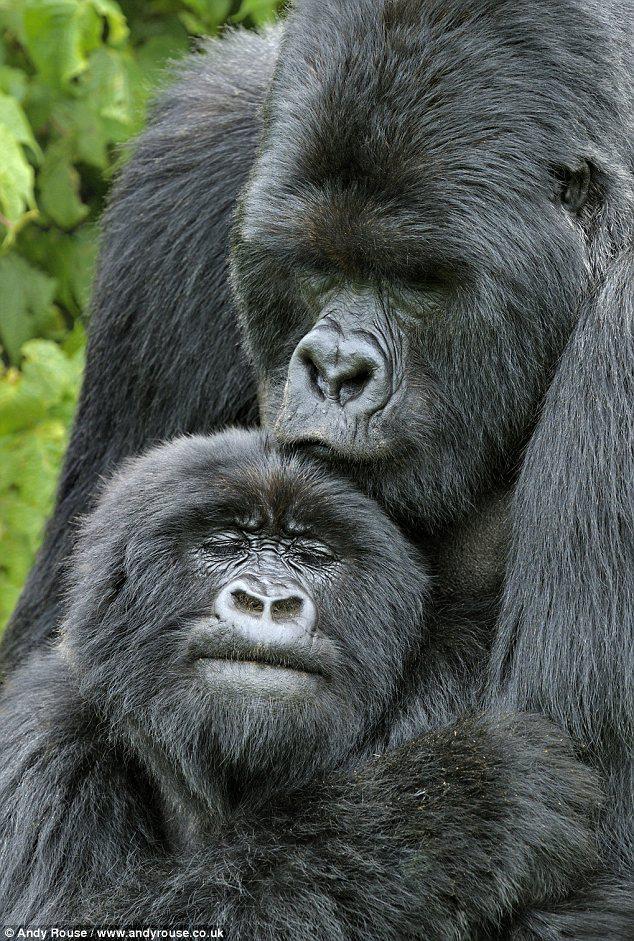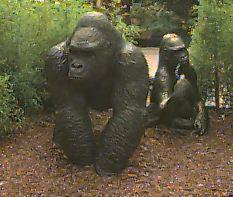The first image is the image on the left, the second image is the image on the right. Examine the images to the left and right. Is the description "There are at most two adult gorillas." accurate? Answer yes or no. Yes. The first image is the image on the left, the second image is the image on the right. Considering the images on both sides, is "In one of the images there is one animal all by itself." valid? Answer yes or no. No. 